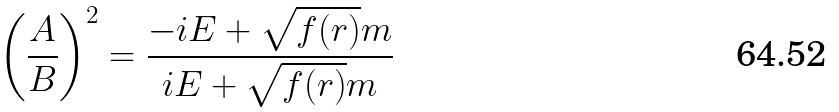Convert formula to latex. <formula><loc_0><loc_0><loc_500><loc_500>\left ( \frac { A } { B } \right ) ^ { 2 } = \frac { - i E + \sqrt { f ( r ) } m } { i E + \sqrt { f ( r ) } m }</formula> 